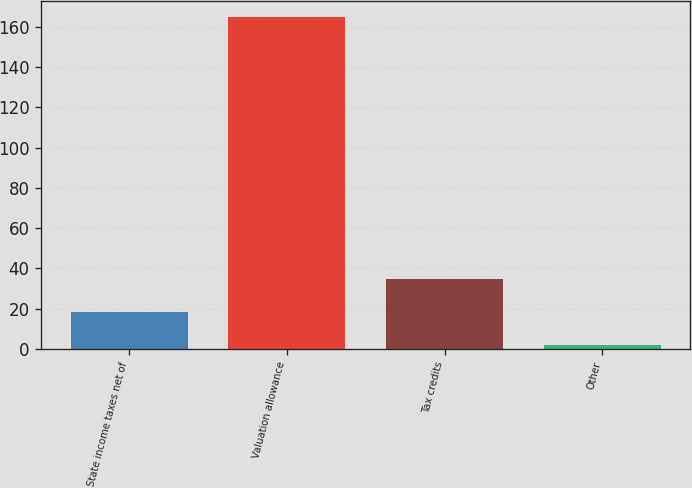<chart> <loc_0><loc_0><loc_500><loc_500><bar_chart><fcel>State income taxes net of<fcel>Valuation allowance<fcel>Tax credits<fcel>Other<nl><fcel>18.28<fcel>164.8<fcel>34.56<fcel>2<nl></chart> 